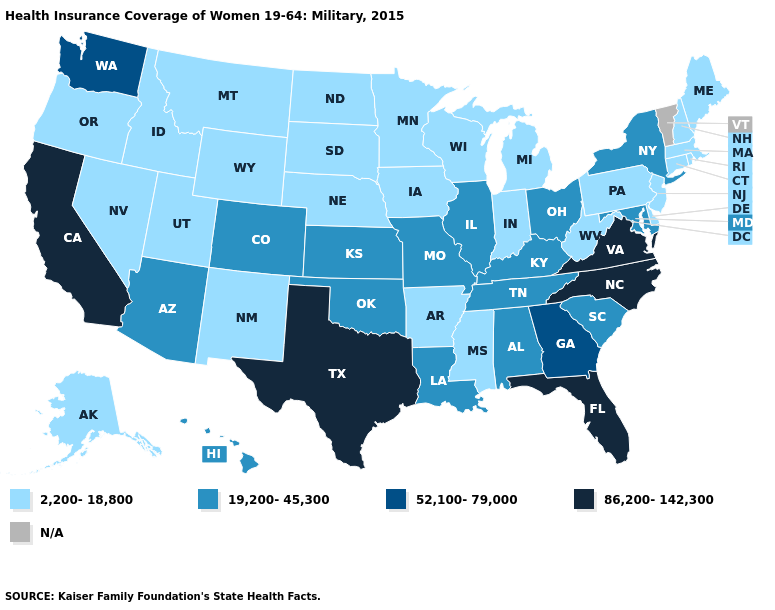Which states have the lowest value in the USA?
Quick response, please. Alaska, Arkansas, Connecticut, Delaware, Idaho, Indiana, Iowa, Maine, Massachusetts, Michigan, Minnesota, Mississippi, Montana, Nebraska, Nevada, New Hampshire, New Jersey, New Mexico, North Dakota, Oregon, Pennsylvania, Rhode Island, South Dakota, Utah, West Virginia, Wisconsin, Wyoming. What is the value of Georgia?
Quick response, please. 52,100-79,000. Does North Carolina have the highest value in the South?
Short answer required. Yes. What is the lowest value in the MidWest?
Be succinct. 2,200-18,800. Name the states that have a value in the range 19,200-45,300?
Quick response, please. Alabama, Arizona, Colorado, Hawaii, Illinois, Kansas, Kentucky, Louisiana, Maryland, Missouri, New York, Ohio, Oklahoma, South Carolina, Tennessee. What is the value of Connecticut?
Keep it brief. 2,200-18,800. Name the states that have a value in the range 86,200-142,300?
Give a very brief answer. California, Florida, North Carolina, Texas, Virginia. What is the value of Wyoming?
Quick response, please. 2,200-18,800. How many symbols are there in the legend?
Short answer required. 5. Does the map have missing data?
Quick response, please. Yes. Does Tennessee have the highest value in the South?
Quick response, please. No. Does California have the lowest value in the USA?
Write a very short answer. No. Does the map have missing data?
Quick response, please. Yes. Does South Carolina have the lowest value in the South?
Quick response, please. No. 